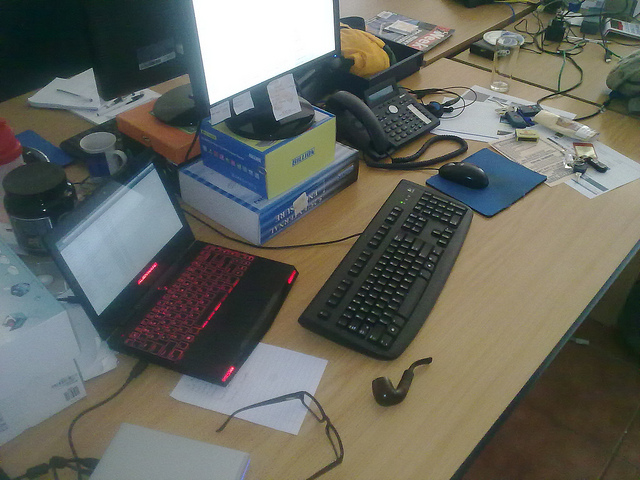How many men are wearing white? The image does not contain any visible individuals, thus it is not possible to determine the clothing color of any people. 